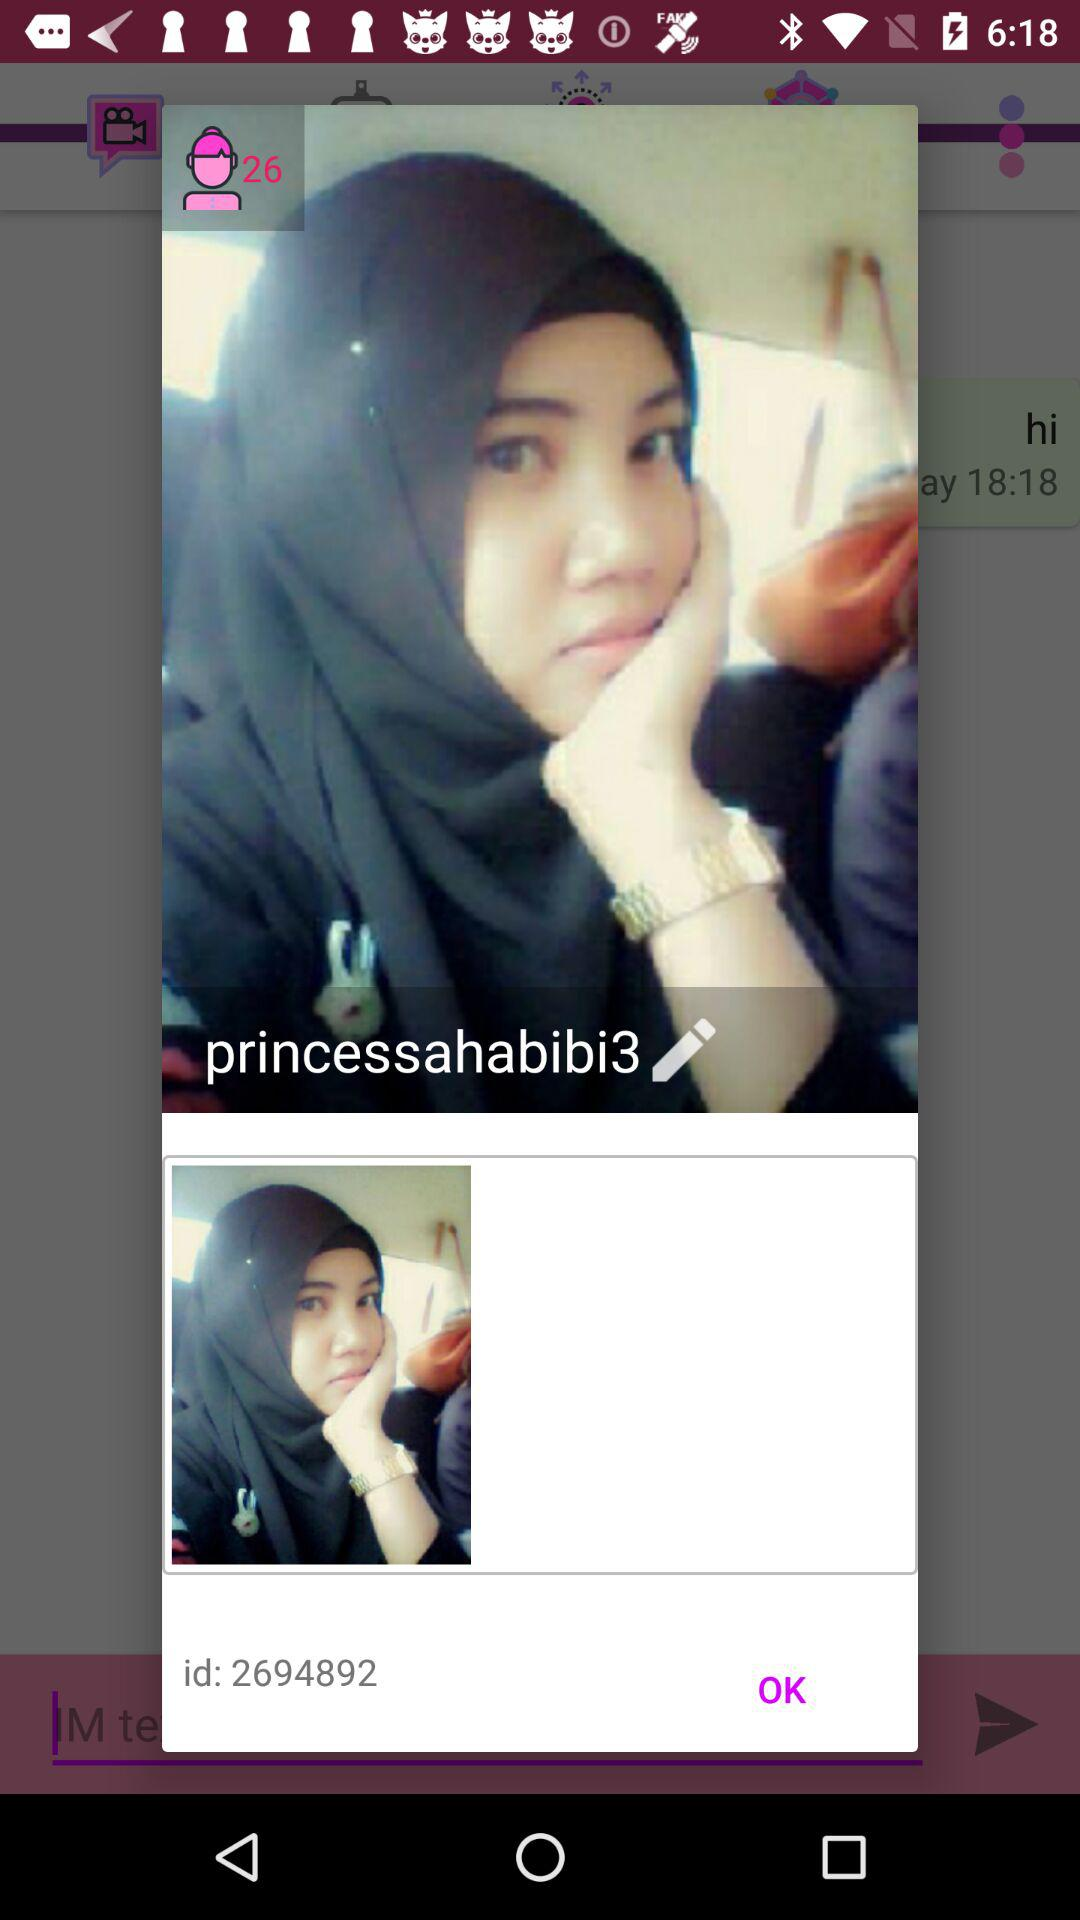What is the username? The username is "princessahabibi3". 